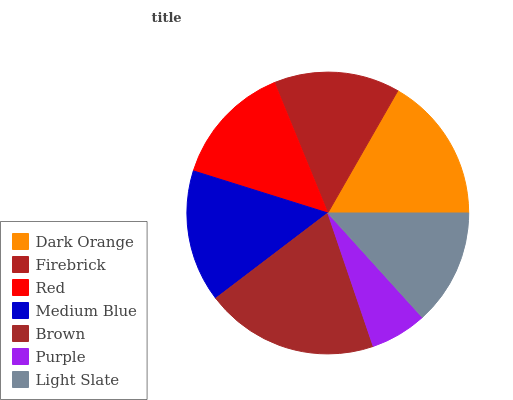Is Purple the minimum?
Answer yes or no. Yes. Is Brown the maximum?
Answer yes or no. Yes. Is Firebrick the minimum?
Answer yes or no. No. Is Firebrick the maximum?
Answer yes or no. No. Is Dark Orange greater than Firebrick?
Answer yes or no. Yes. Is Firebrick less than Dark Orange?
Answer yes or no. Yes. Is Firebrick greater than Dark Orange?
Answer yes or no. No. Is Dark Orange less than Firebrick?
Answer yes or no. No. Is Firebrick the high median?
Answer yes or no. Yes. Is Firebrick the low median?
Answer yes or no. Yes. Is Light Slate the high median?
Answer yes or no. No. Is Dark Orange the low median?
Answer yes or no. No. 